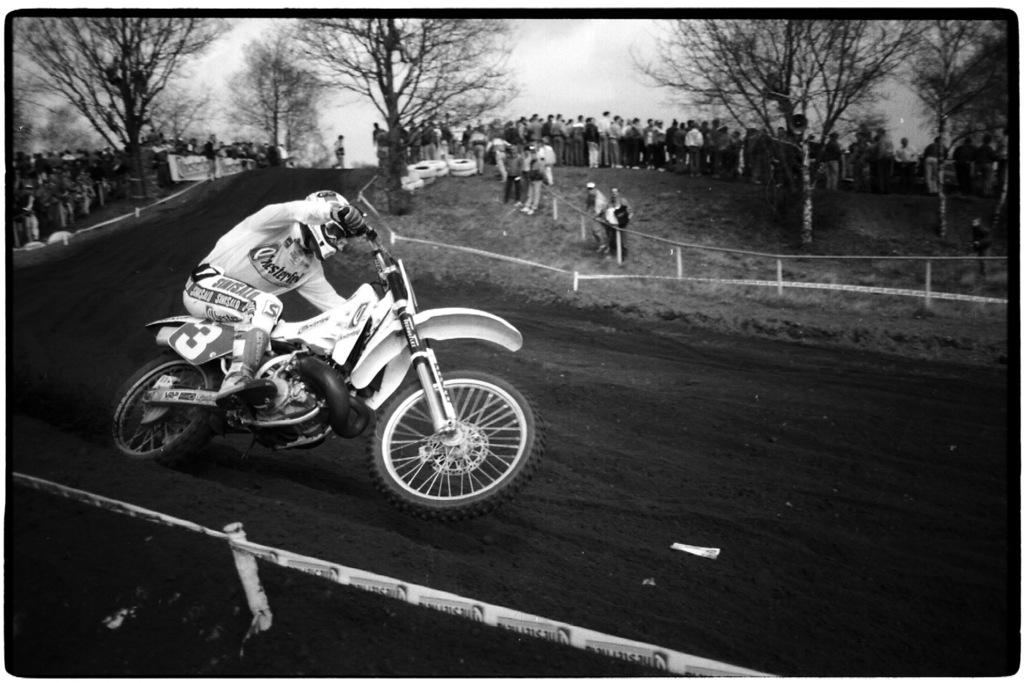What is the main subject of the image? The main subject of the image is a person riding a motorbike. Where is the person riding the motorbike? The person is on a race track. What are the people behind the rider doing? The people are standing behind the rider and watching him. What can be seen in the background of the image? There are trees present in the image. What type of system is being used to prepare the feast in the image? There is no feast or system present in the image; it features a person riding a motorbike on a race track with people watching. 